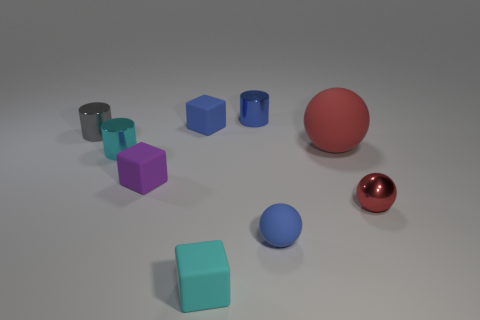What number of small metal objects are left of the blue rubber object that is in front of the tiny gray metallic thing? 3 